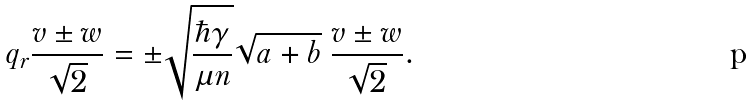Convert formula to latex. <formula><loc_0><loc_0><loc_500><loc_500>\ q _ { r } \frac { v \pm w } { \sqrt { 2 } } = \pm \sqrt { \frac { \hbar { \gamma } } { \mu n } } \sqrt { a + b } \ \frac { v \pm w } { \sqrt { 2 } } .</formula> 